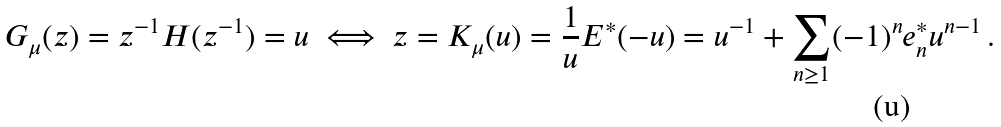Convert formula to latex. <formula><loc_0><loc_0><loc_500><loc_500>G _ { \mu } ( z ) = z ^ { - 1 } H ( z ^ { - 1 } ) = u \ \Longleftrightarrow \ z = K _ { \mu } ( u ) = \frac { 1 } { u } E ^ { * } ( - u ) = u ^ { - 1 } + \sum _ { n \geq 1 } ( - 1 ) ^ { n } e _ { n } ^ { * } u ^ { n - 1 } \, .</formula> 